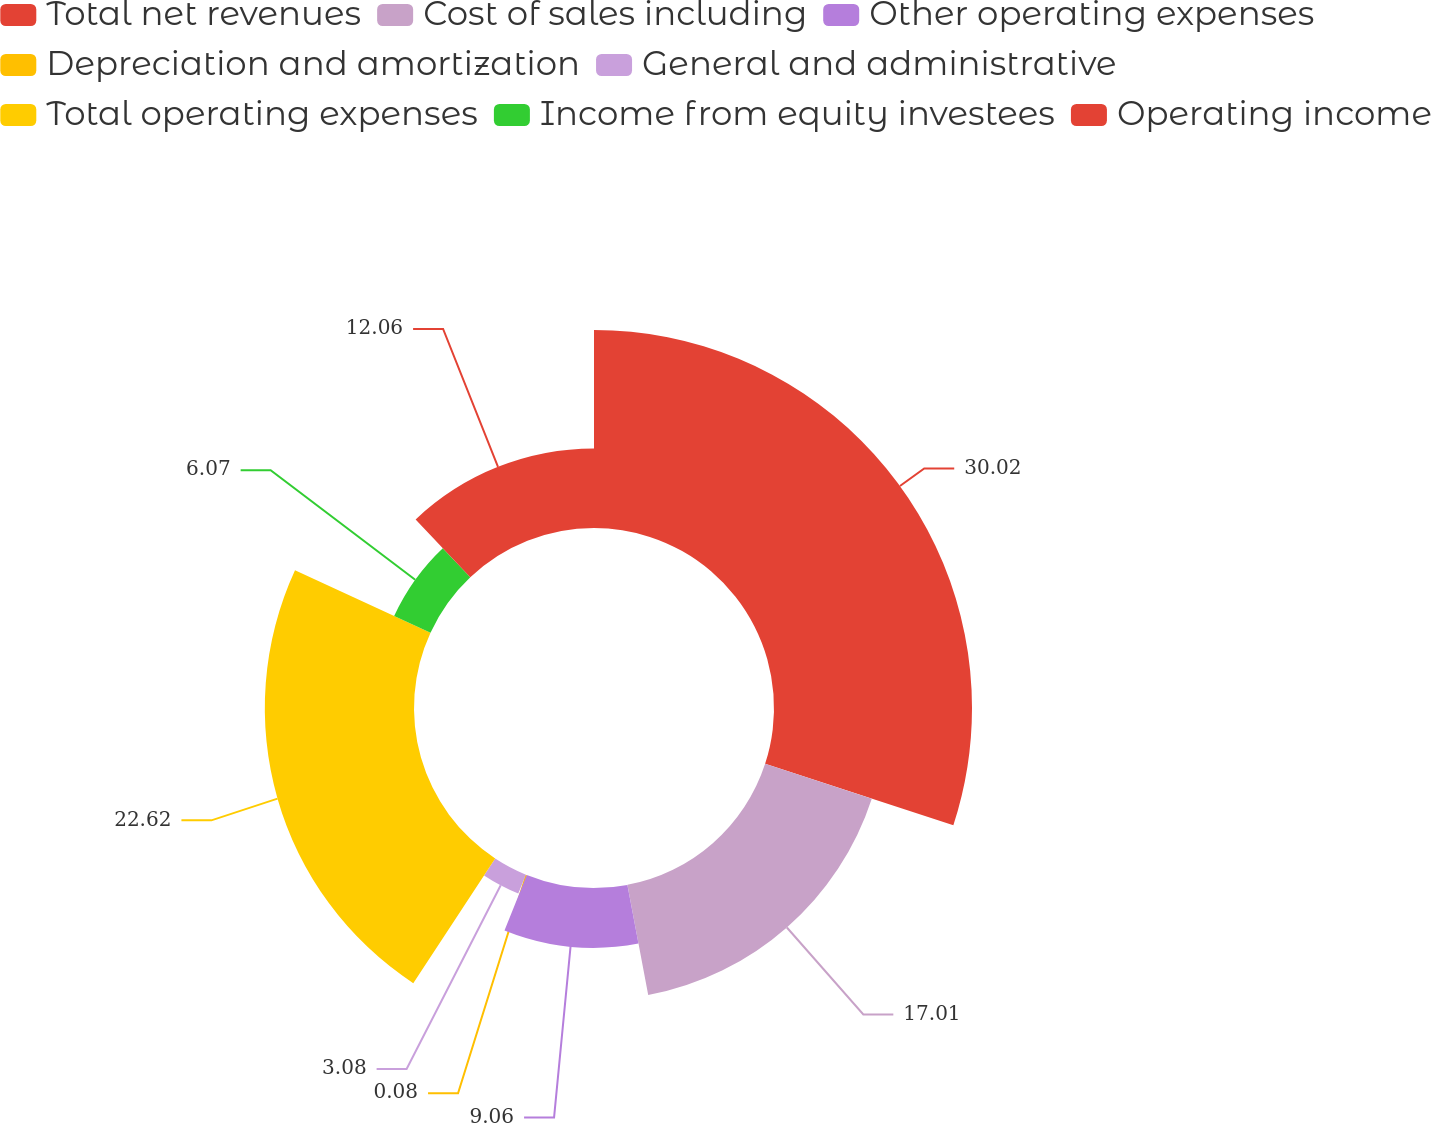Convert chart. <chart><loc_0><loc_0><loc_500><loc_500><pie_chart><fcel>Total net revenues<fcel>Cost of sales including<fcel>Other operating expenses<fcel>Depreciation and amortization<fcel>General and administrative<fcel>Total operating expenses<fcel>Income from equity investees<fcel>Operating income<nl><fcel>30.02%<fcel>17.01%<fcel>9.06%<fcel>0.08%<fcel>3.08%<fcel>22.62%<fcel>6.07%<fcel>12.06%<nl></chart> 